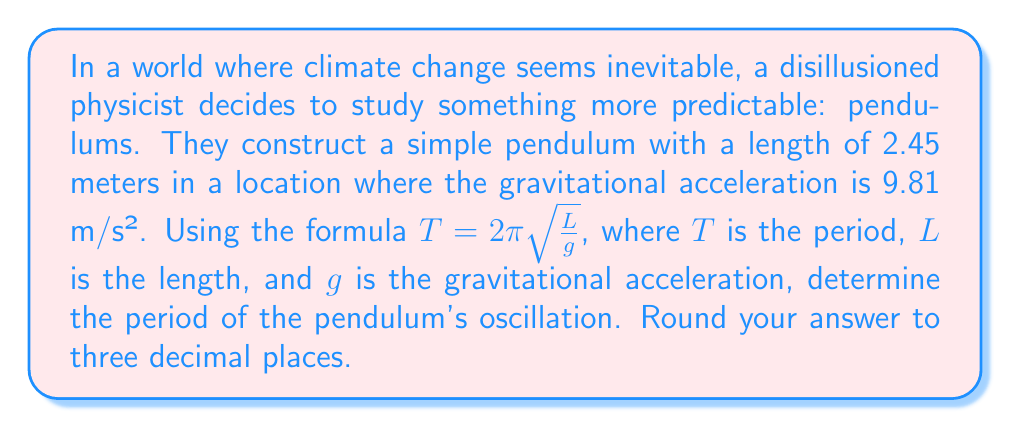Could you help me with this problem? Let's approach this step-by-step:

1) We are given the formula for the period of a simple pendulum:

   $T = 2\pi\sqrt{\frac{L}{g}}$

2) We know the following values:
   - $L = 2.45$ meters
   - $g = 9.81$ m/s²

3) Let's substitute these values into the formula:

   $T = 2\pi\sqrt{\frac{2.45}{9.81}}$

4) First, let's calculate what's inside the square root:

   $\frac{2.45}{9.81} \approx 0.2497$

5) Now, let's take the square root:

   $\sqrt{0.2497} \approx 0.4997$

6) Multiply this by $2\pi$:

   $2\pi * 0.4997 \approx 3.1396$

7) Rounding to three decimal places:

   $T \approx 3.140$ seconds
Answer: 3.140 seconds 